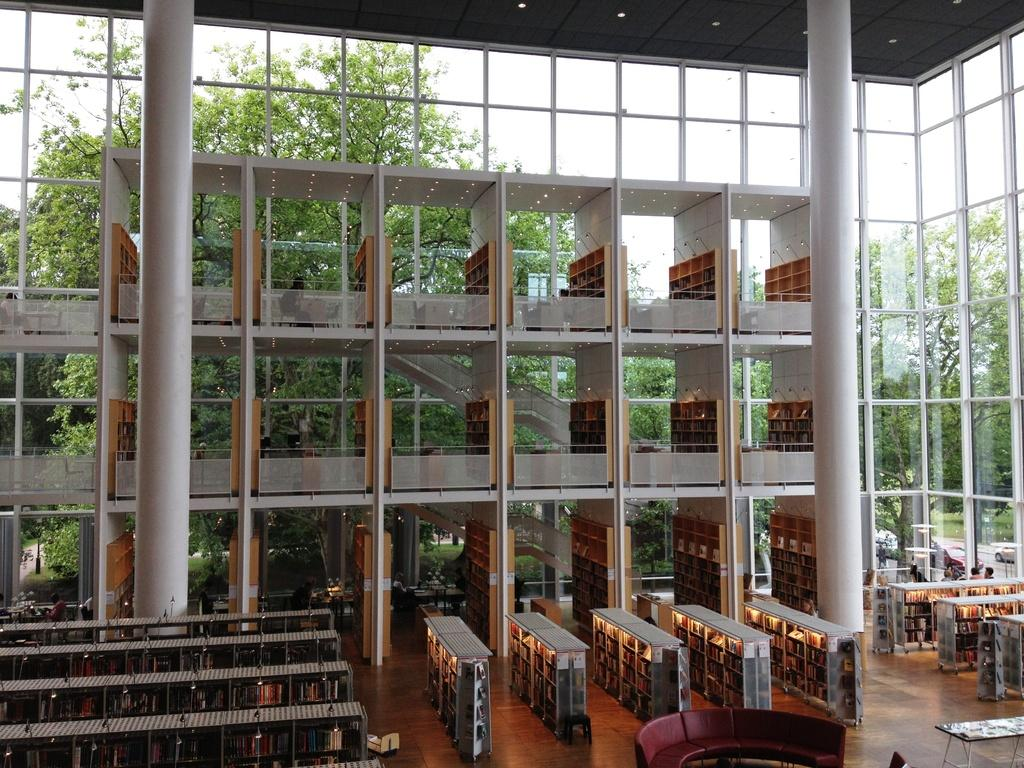What type of location is depicted in the image? The image shows an inside view of a building. What architectural features can be seen in the image? There are pillars visible in the image. What part of the building can be seen in the image? The floor is visible in the image. Who or what is present in the image? There are people and objects present in the image. What can be seen in the background of the image? Trees, vehicles, and the sky are visible in the background of the image. What type of tin is being washed by the people in the image? There is no tin present in the image, nor are people washing anything. What type of wine is being served to the people in the image? There is no wine present in the image, nor are people being served any beverages. 